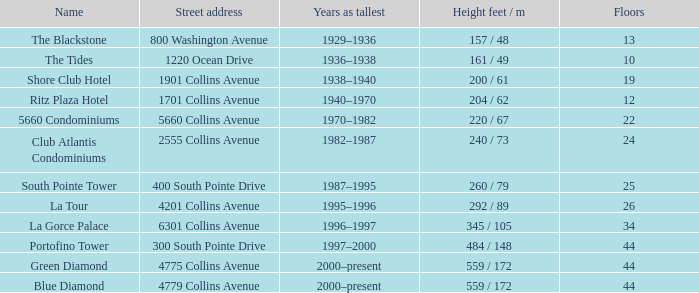What is the height of the Tides with less than 34 floors? 161 / 49. 